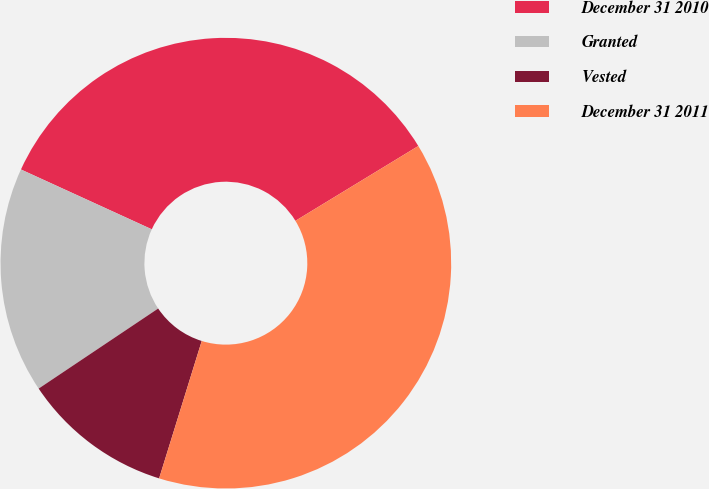<chart> <loc_0><loc_0><loc_500><loc_500><pie_chart><fcel>December 31 2010<fcel>Granted<fcel>Vested<fcel>December 31 2011<nl><fcel>34.47%<fcel>16.22%<fcel>10.82%<fcel>38.49%<nl></chart> 